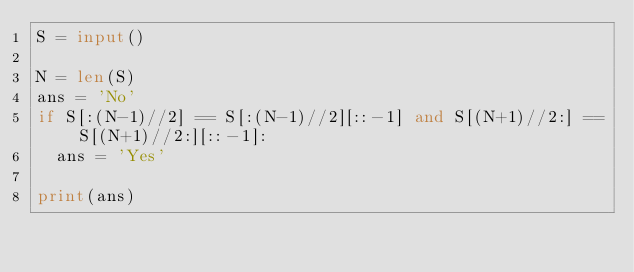<code> <loc_0><loc_0><loc_500><loc_500><_Python_>S = input()

N = len(S)
ans = 'No'
if S[:(N-1)//2] == S[:(N-1)//2][::-1] and S[(N+1)//2:] == S[(N+1)//2:][::-1]:
  ans = 'Yes'
  
print(ans)</code> 